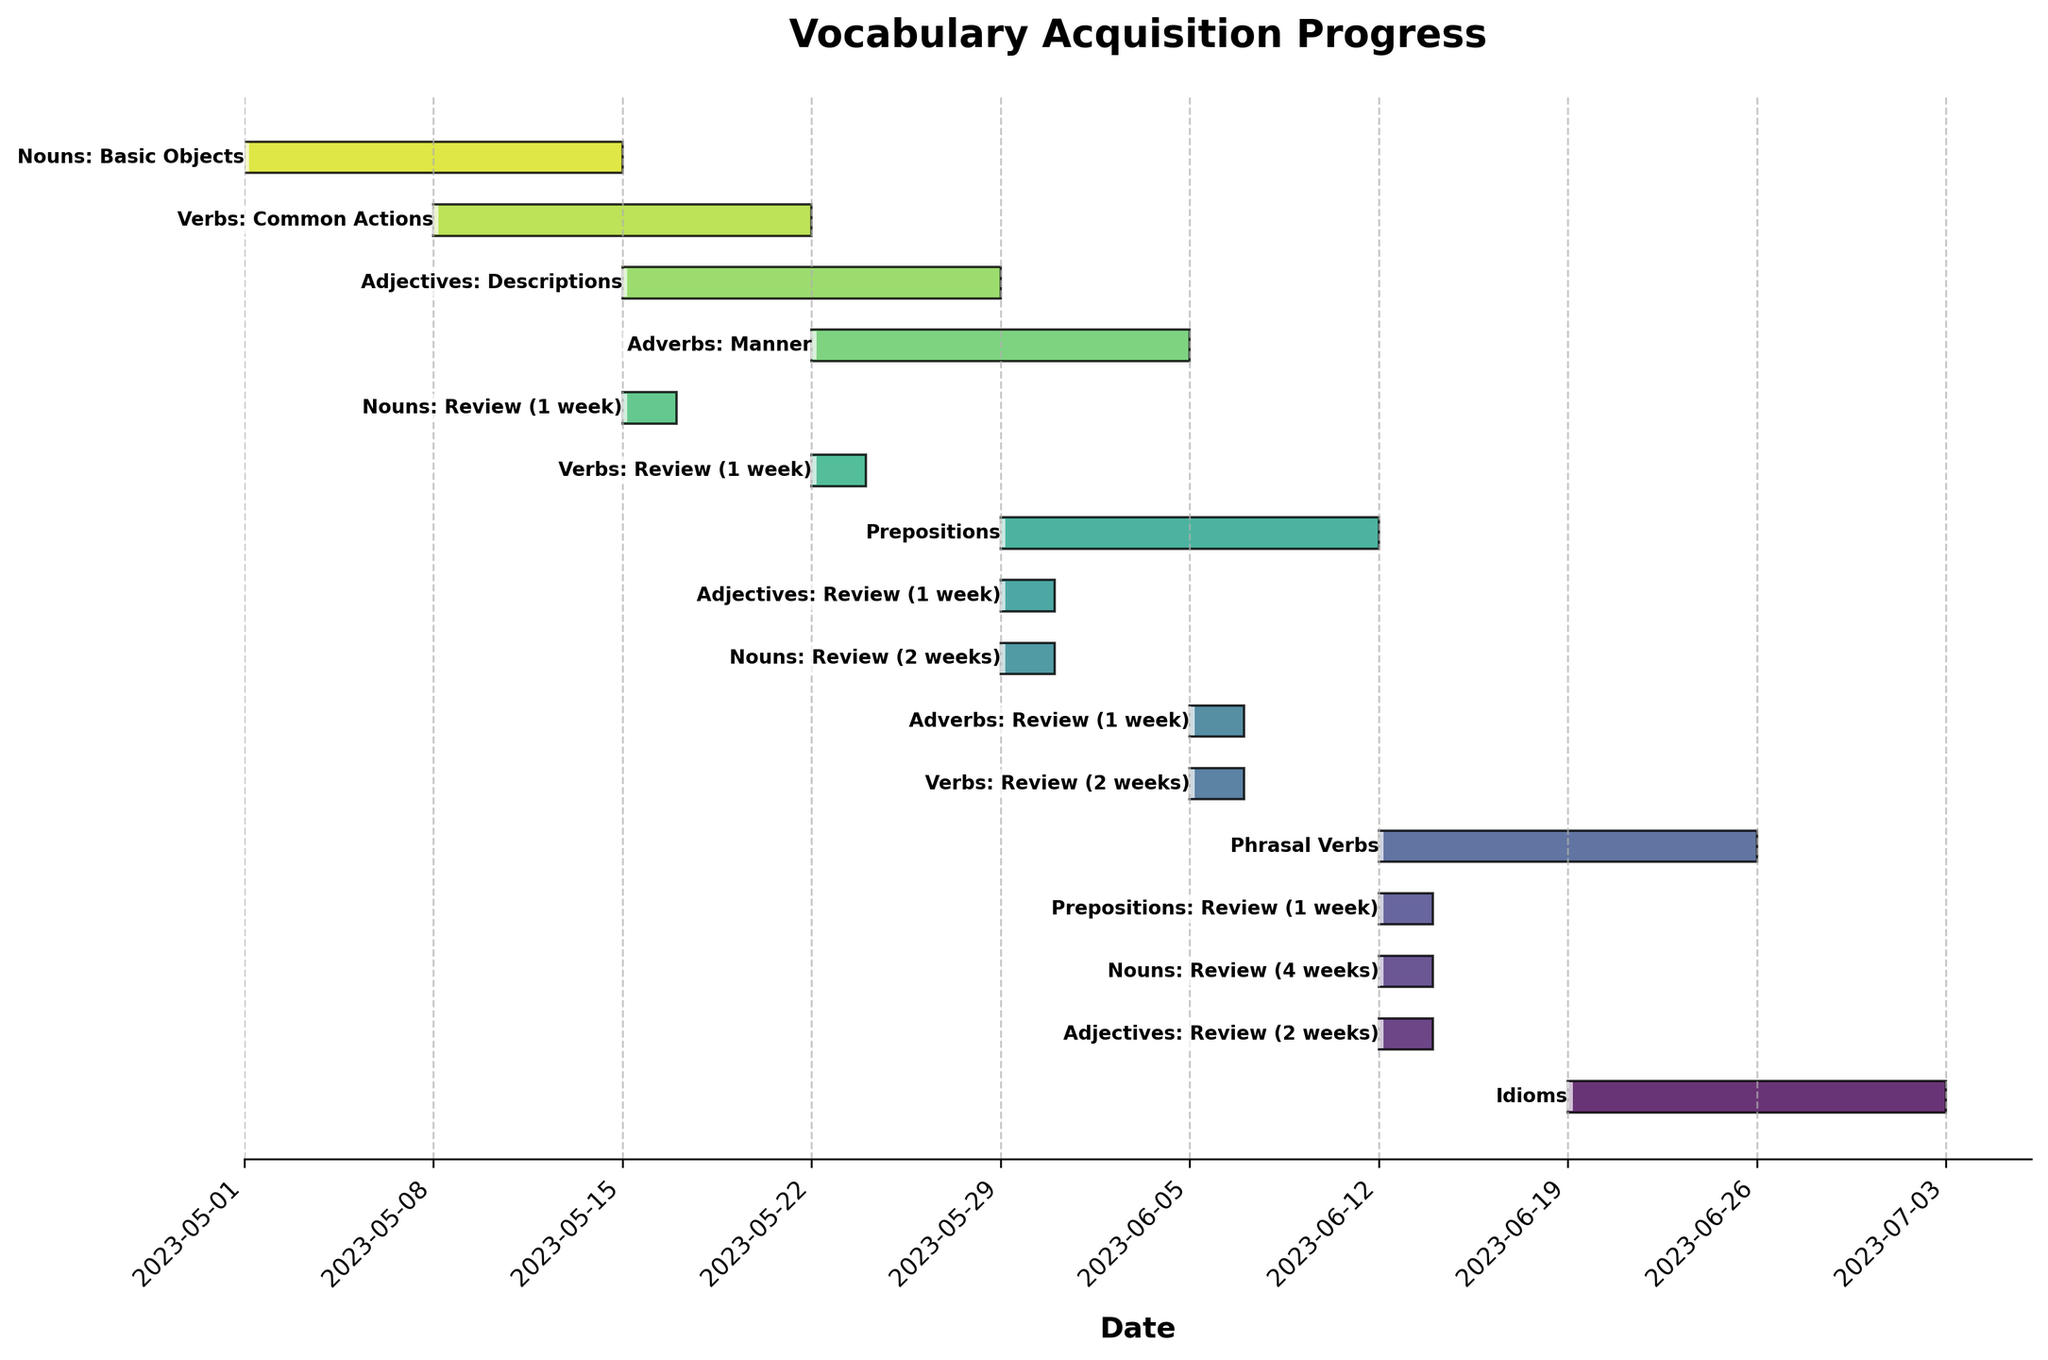What is the title of the Gantt chart? The title of the chart is typically displayed at the top of the figure, summarizing the main topic of the visualization. In this case, the title is found prominently positioned and should be simple to identify.
Answer: Vocabulary Acquisition Progress How many categories are there in the chart? To determine the number of categories, count the unique task names listed on the vertical axis. Each bar represents a different task category related to vocabulary acquisition.
Answer: 15 Which vocabulary category is studied first? Look at the starting dates of each task. The task that starts on the earliest date will be the first category studied. According to the chart, this category is the first listed bar on the left.
Answer: Nouns: Basic Objects How many review intervals are there for Nouns? Find the bars associated with the "Nouns" category and count those specifically marked for review. These intervals indicate scheduled review periods after the initial study phase.
Answer: 3 Which task has the longest duration? Duration can be calculated by looking at the length of each bar. The task with the longest horizontal bar has the longest duration between its start and end dates.
Answer: Nouns: Basic Objects, Verbs: Common Actions, Adjectives: Descriptions, Adverbs: Manner, Prepositions, Phrasal Verbs, Idioms (all 14 days) What is the total duration of the Nouns: Basic Objects task, including all review intervals? Identify the initial duration of "Nouns: Basic Objects" and add the durations of all its review intervals (each review has its own bar). The sum provides the total duration.
Answer: 20 days Which task overlaps with "Adjectives: Descriptions" starting from its first day? Examine bars that start on or before the start date of "Adjectives: Descriptions" (2023-05-15) and overlap with the horizon from there.
Answer: Nouns: Basic Objects and Verbs: Common Actions Which task begins exactly one week after "Adverbs: Manner" starts? Determine the start date of "Adverbs: Manner" and add one week to see which task starts on this new date.
Answer: Prepositions How long after the start of "Verbs: Common Actions" does "Verbs: Review (2 weeks)" take place? Note the start date of "Verbs: Common Actions" and the start date of "Verbs: Review (2 weeks)". Calculate the time difference between these two dates.
Answer: 28 days 